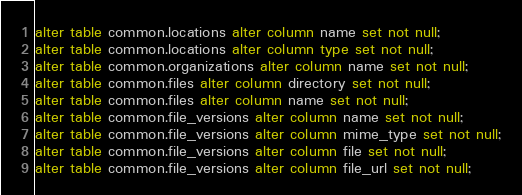<code> <loc_0><loc_0><loc_500><loc_500><_SQL_>alter table common.locations alter column name set not null;
alter table common.locations alter column type set not null;
alter table common.organizations alter column name set not null;
alter table common.files alter column directory set not null;
alter table common.files alter column name set not null;
alter table common.file_versions alter column name set not null;
alter table common.file_versions alter column mime_type set not null;
alter table common.file_versions alter column file set not null;
alter table common.file_versions alter column file_url set not null;
</code> 